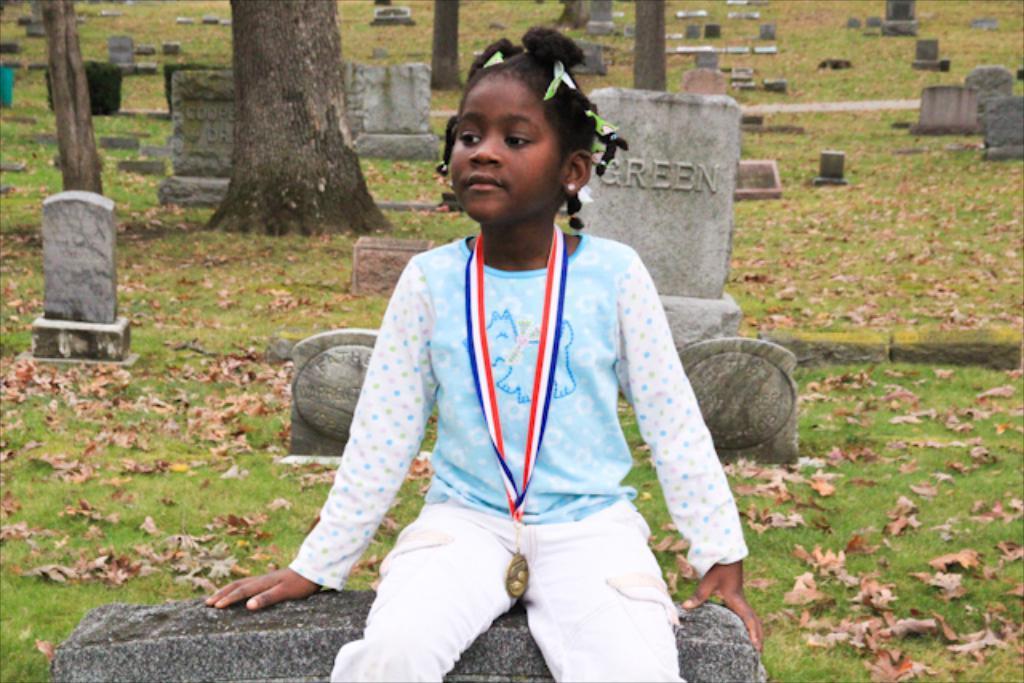Please provide a concise description of this image. In the picture we can see a graveyard with grass surface, trees and grave stones on it and on the gravestone we can see a girl sitting on it and she is with white clothes with a medal. 